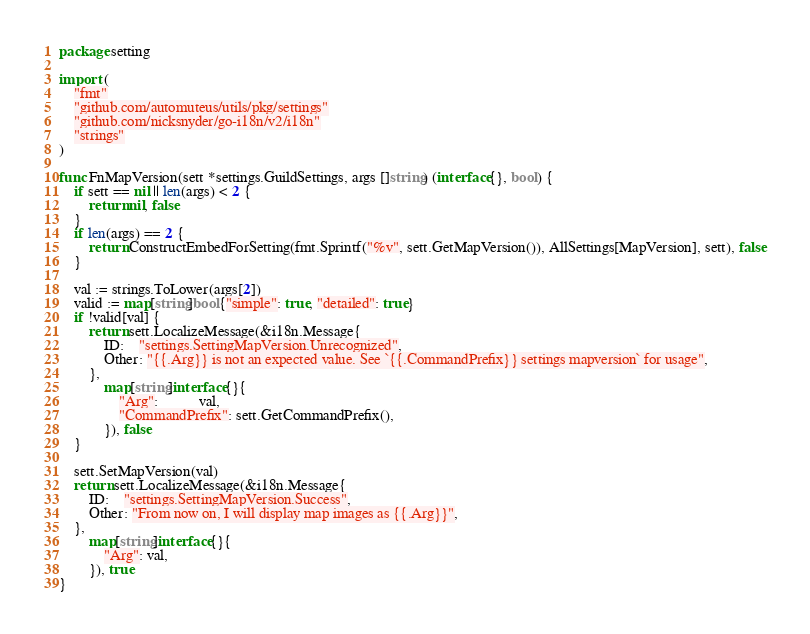<code> <loc_0><loc_0><loc_500><loc_500><_Go_>package setting

import (
	"fmt"
	"github.com/automuteus/utils/pkg/settings"
	"github.com/nicksnyder/go-i18n/v2/i18n"
	"strings"
)

func FnMapVersion(sett *settings.GuildSettings, args []string) (interface{}, bool) {
	if sett == nil || len(args) < 2 {
		return nil, false
	}
	if len(args) == 2 {
		return ConstructEmbedForSetting(fmt.Sprintf("%v", sett.GetMapVersion()), AllSettings[MapVersion], sett), false
	}

	val := strings.ToLower(args[2])
	valid := map[string]bool{"simple": true, "detailed": true}
	if !valid[val] {
		return sett.LocalizeMessage(&i18n.Message{
			ID:    "settings.SettingMapVersion.Unrecognized",
			Other: "{{.Arg}} is not an expected value. See `{{.CommandPrefix}} settings mapversion` for usage",
		},
			map[string]interface{}{
				"Arg":           val,
				"CommandPrefix": sett.GetCommandPrefix(),
			}), false
	}

	sett.SetMapVersion(val)
	return sett.LocalizeMessage(&i18n.Message{
		ID:    "settings.SettingMapVersion.Success",
		Other: "From now on, I will display map images as {{.Arg}}",
	},
		map[string]interface{}{
			"Arg": val,
		}), true
}
</code> 